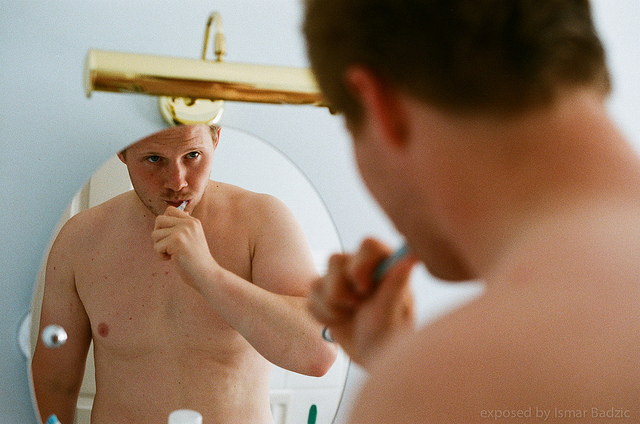Identify and read out the text in this image. by Ismar Badzic 